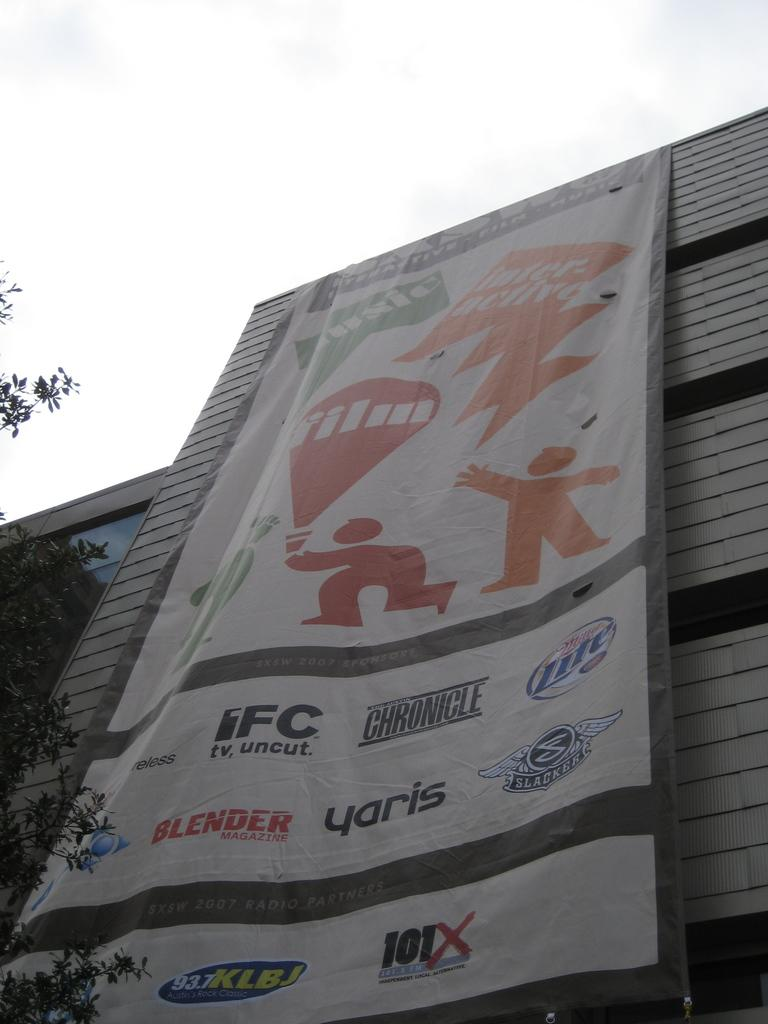What is on the building in the image? There is a poster on a building in the image. What can be seen in the foreground of the image? There is a tree in the foreground of the image. What is visible in the background of the image? The sky is visible in the background of the image. Can you tell me how many patches of grass are visible in the image? There is no mention of grass in the provided facts, so it is not possible to determine the number of patches of grass in the image. Is anyone swimming in the image? There is no indication of water or swimming in the image, so it is not possible to determine if anyone is swimming. 